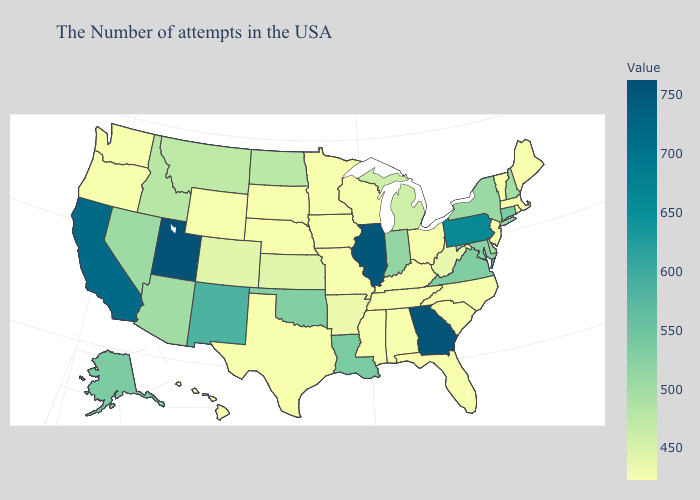Does Iowa have the lowest value in the USA?
Be succinct. Yes. Does the map have missing data?
Quick response, please. No. Does Pennsylvania have a higher value than Alaska?
Concise answer only. Yes. Does West Virginia have the lowest value in the South?
Give a very brief answer. No. Is the legend a continuous bar?
Be succinct. Yes. 